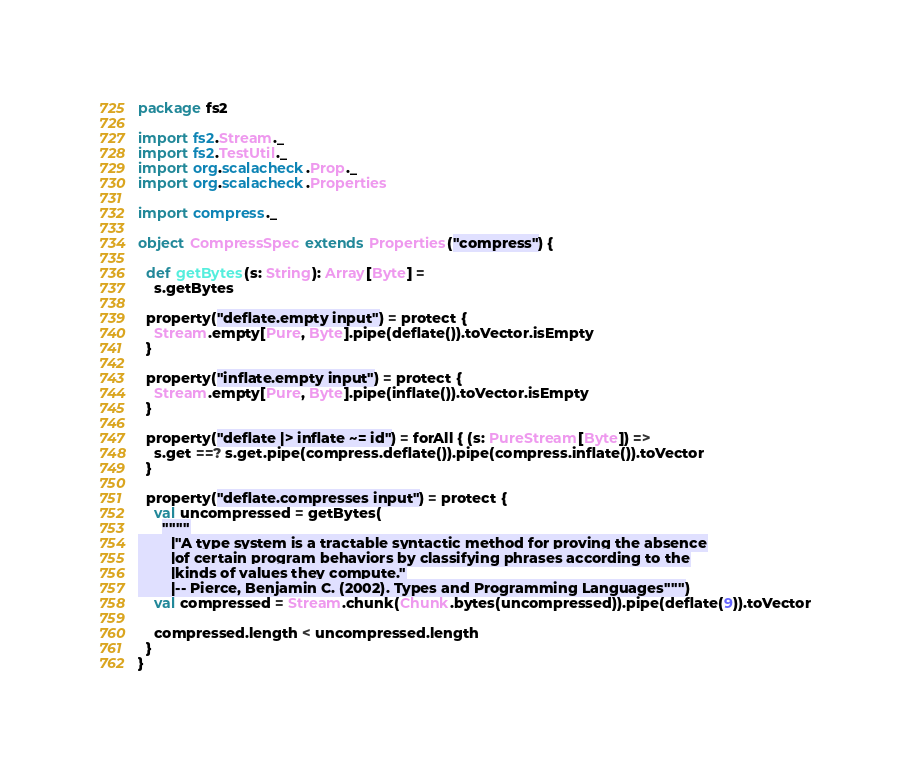Convert code to text. <code><loc_0><loc_0><loc_500><loc_500><_Scala_>package fs2

import fs2.Stream._
import fs2.TestUtil._
import org.scalacheck.Prop._
import org.scalacheck.Properties

import compress._

object CompressSpec extends Properties("compress") {

  def getBytes(s: String): Array[Byte] =
    s.getBytes

  property("deflate.empty input") = protect {
    Stream.empty[Pure, Byte].pipe(deflate()).toVector.isEmpty
  }

  property("inflate.empty input") = protect {
    Stream.empty[Pure, Byte].pipe(inflate()).toVector.isEmpty
  }

  property("deflate |> inflate ~= id") = forAll { (s: PureStream[Byte]) =>
    s.get ==? s.get.pipe(compress.deflate()).pipe(compress.inflate()).toVector
  }

  property("deflate.compresses input") = protect {
    val uncompressed = getBytes(
      """"
        |"A type system is a tractable syntactic method for proving the absence
        |of certain program behaviors by classifying phrases according to the
        |kinds of values they compute."
        |-- Pierce, Benjamin C. (2002). Types and Programming Languages""")
    val compressed = Stream.chunk(Chunk.bytes(uncompressed)).pipe(deflate(9)).toVector

    compressed.length < uncompressed.length
  }
}
</code> 